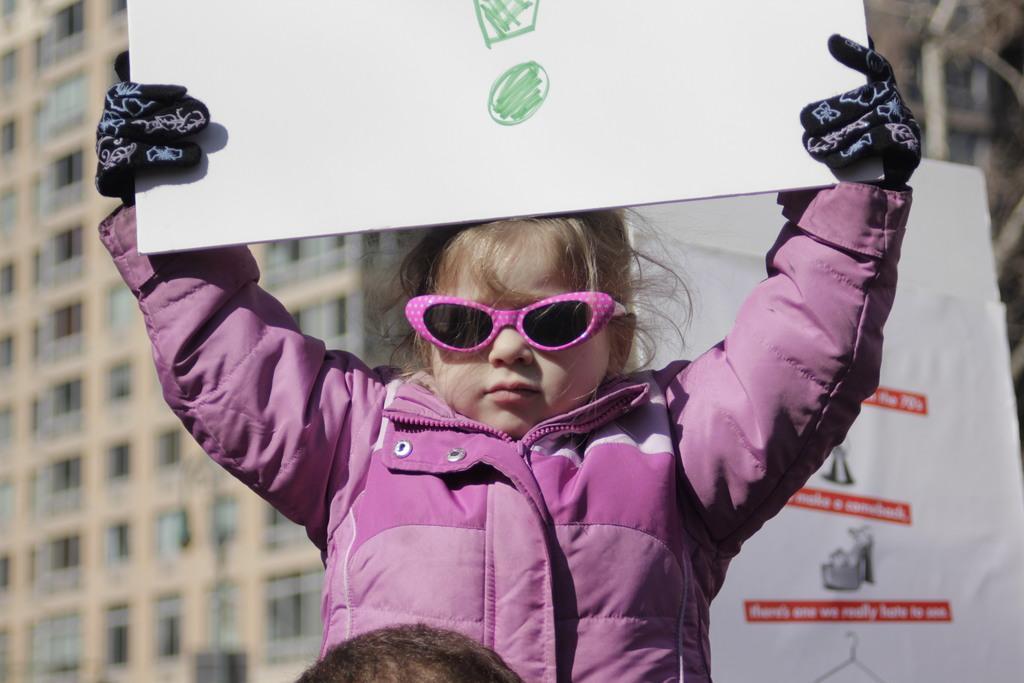Can you describe this image briefly? In this image, we can see a kid holding a poster, in the background, there is a building and we can see some windows on the building. 